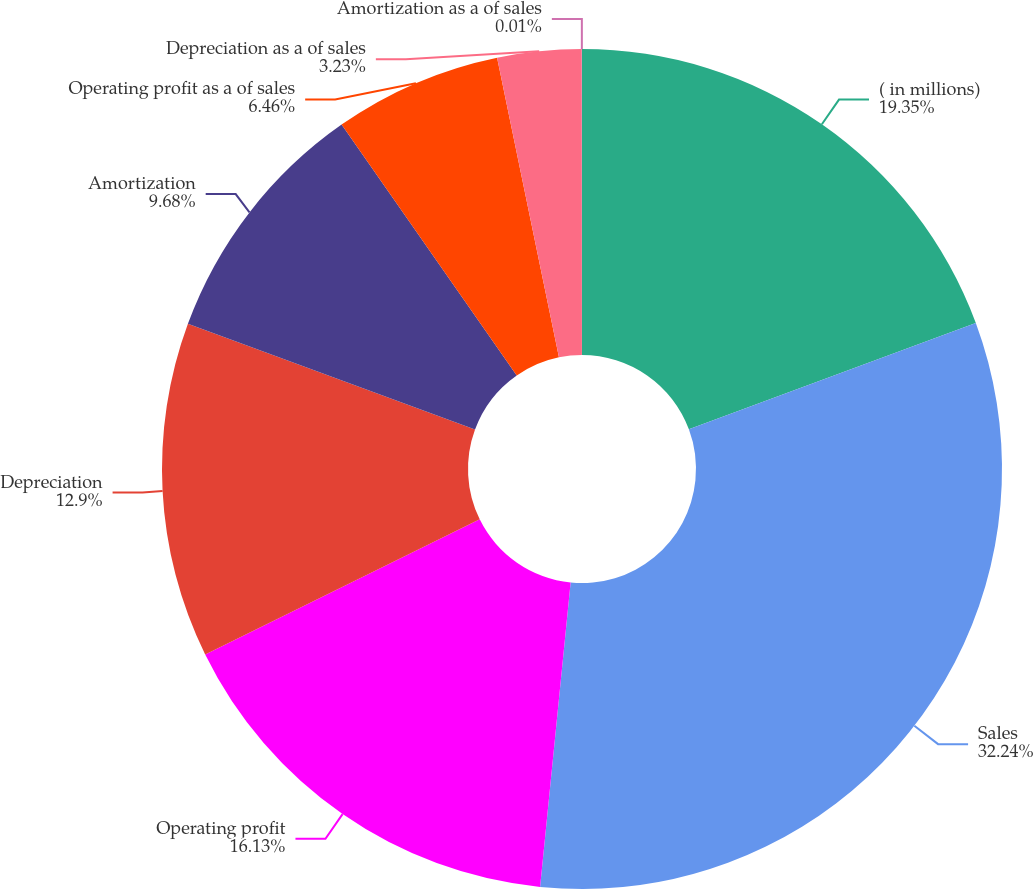Convert chart. <chart><loc_0><loc_0><loc_500><loc_500><pie_chart><fcel>( in millions)<fcel>Sales<fcel>Operating profit<fcel>Depreciation<fcel>Amortization<fcel>Operating profit as a of sales<fcel>Depreciation as a of sales<fcel>Amortization as a of sales<nl><fcel>19.35%<fcel>32.24%<fcel>16.13%<fcel>12.9%<fcel>9.68%<fcel>6.46%<fcel>3.23%<fcel>0.01%<nl></chart> 